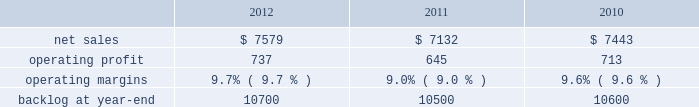2011 compared to 2010 mfc 2019s net sales for 2011 increased $ 533 million , or 8% ( 8 % ) , compared to 2010 .
The increase was attributable to higher volume of about $ 420 million on air and missile defense programs ( primarily pac-3 and thaad ) ; and about $ 245 million from fire control systems programs primarily related to the sof clss program , which began late in the third quarter of 2010 .
Partially offsetting these increases were lower net sales due to decreased volume of approximately $ 75 million primarily from various services programs and approximately $ 20 million from tactical missile programs ( primarily mlrs and jassm ) .
Mfc 2019s operating profit for 2011 increased $ 96 million , or 10% ( 10 % ) , compared to 2010 .
The increase was attributable to higher operating profit of about $ 60 million for air and missile defense programs ( primarily pac-3 and thaad ) as a result of increased volume and retirement of risks ; and approximately $ 25 million for various services programs .
Adjustments not related to volume , including net profit rate adjustments described above , were approximately $ 35 million higher in 2011 compared to 2010 .
Backlog backlog increased in 2012 compared to 2011 mainly due to increased orders and lower sales on fire control systems programs ( primarily lantirn ae and sniper ae ) and on various services programs , partially offset by lower orders and higher sales volume on tactical missiles programs .
Backlog increased in 2011 compared to 2010 primarily due to increased orders on air and missile defense programs ( primarily thaad ) .
Trends we expect mfc 2019s net sales for 2013 will be comparable with 2012 .
We expect low double digit percentage growth in air and missile defense programs , offset by an expected decline in volume on logistics services programs .
Operating profit and margin are expected to be comparable with 2012 results .
Mission systems and training our mst business segment provides surface ship and submarine combat systems ; sea and land-based missile defense systems ; radar systems ; mission systems and sensors for rotary and fixed-wing aircraft ; littoral combat ships ; simulation and training services ; unmanned technologies and platforms ; ship systems integration ; and military and commercial training systems .
Mst 2019s major programs include aegis , mk-41 vertical launching system ( vls ) , tpq-53 radar system , mh-60 , lcs , and ptds .
Mst 2019s operating results included the following ( in millions ) : .
2012 compared to 2011 mst 2019s net sales for 2012 increased $ 447 million , or 6% ( 6 % ) , compared to 2011 .
The increase in net sales for 2012 was attributable to higher volume and risk retirements of approximately $ 395 million from ship and aviation system programs ( primarily ptds ; lcs ; vls ; and mh-60 ) ; about $ 115 million for training and logistics solutions programs primarily due to net sales from sim industries , which was acquired in the fourth quarter of 2011 ; and approximately $ 30 million as a result of increased volume on integrated warfare systems and sensors programs ( primarily aegis ) .
Partially offsetting the increases were lower net sales of approximately $ 70 million from undersea systems programs due to lower volume on an international combat system program and towed array systems ; and about $ 25 million due to lower volume on various other programs .
Mst 2019s operating profit for 2012 increased $ 92 million , or 14% ( 14 % ) , compared to 2011 .
The increase was attributable to higher operating profit of approximately $ 175 million from ship and aviation system programs , which reflects higher volume and risk retirements on certain programs ( primarily vls ; ptds ; mh-60 ; and lcs ) and reserves of about $ 55 million for contract cost matters on ship and aviation system programs recorded in the fourth quarter of 2011 ( including the terminated presidential helicopter program ) .
Partially offsetting the increase was lower operating profit of approximately $ 40 million from undersea systems programs due to reduced profit booking rates on certain programs and lower volume on an international combat system program and towed array systems ; and about $ 40 million due to lower volume on various other programs .
Adjustments not related to volume , including net profit booking rate adjustments and other matters described above , were approximately $ 150 million higher for 2012 compared to 2011. .
What was the percent of the decline in the mst net sales from 2010 to 2011? 
Computations: ((7132 - 7443) / 7443)
Answer: -0.04178. 